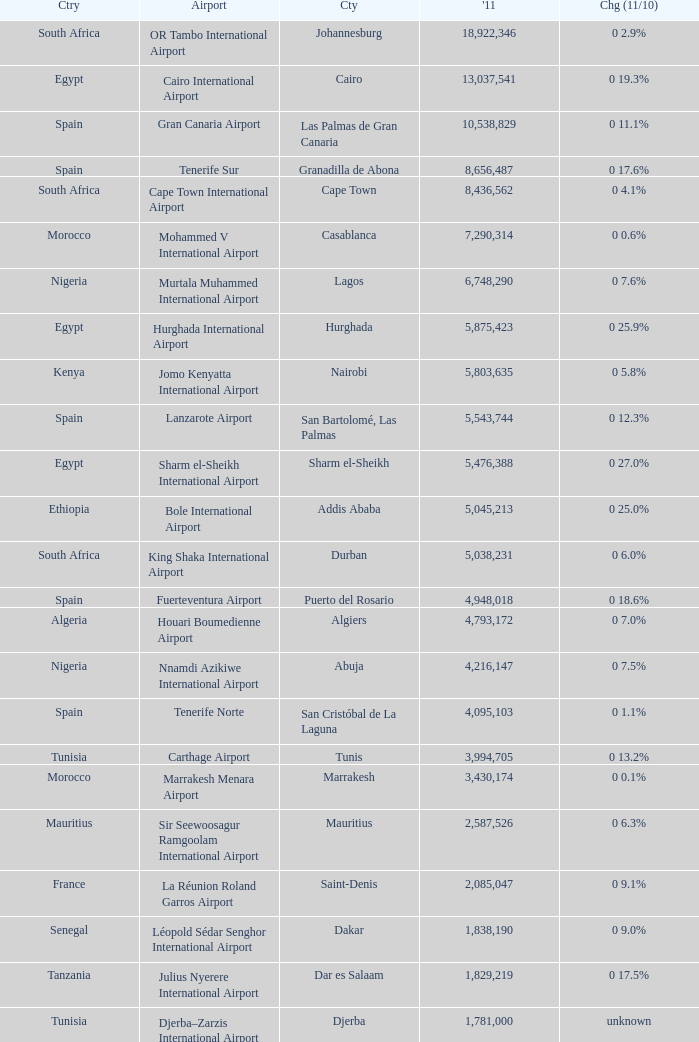Which 2011 has an Airport of bole international airport? 5045213.0. 